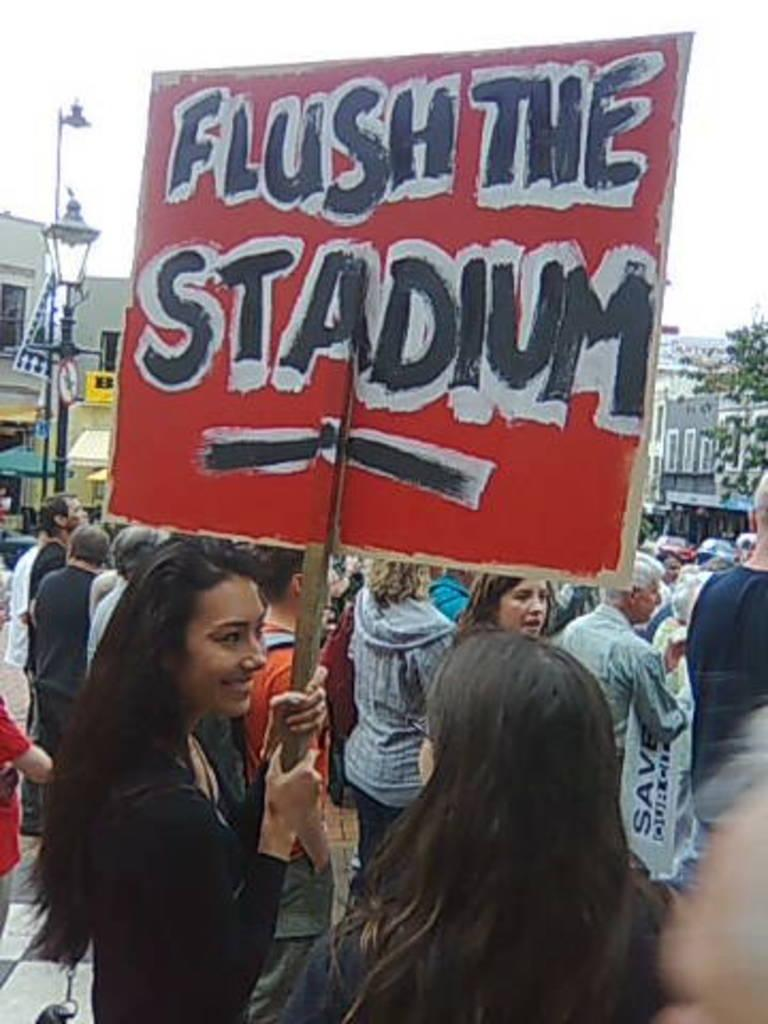Who is the main subject in the image? There is a woman in the image. What is the woman holding in the image? The woman is holding a board with her hands. What is the woman's facial expression in the image? The woman is smiling. What is happening in the image involving other people? There are people protesting in the image. What can be seen in the background of the image? There are buildings, the sky, and a tree in the background of the image. What type of bath can be seen in the image? There is no bath present in the image. What is the argument about in the image? There is no argument depicted in the image; it shows people protesting. 